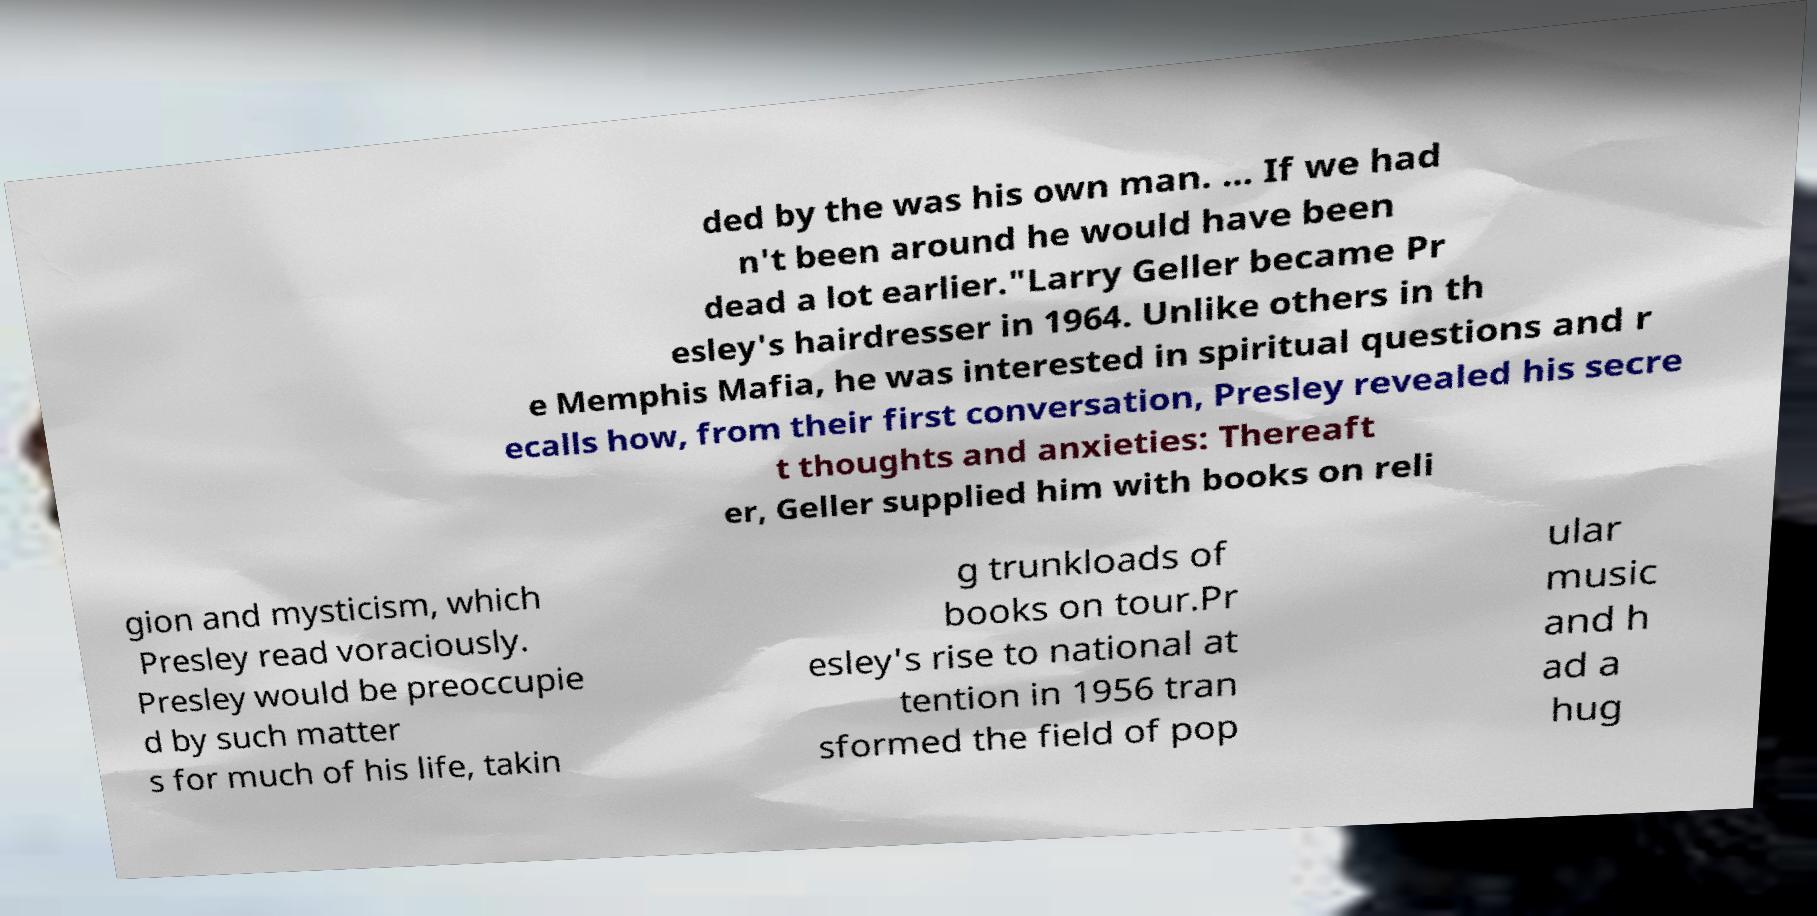What messages or text are displayed in this image? I need them in a readable, typed format. ded by the was his own man. ... If we had n't been around he would have been dead a lot earlier."Larry Geller became Pr esley's hairdresser in 1964. Unlike others in th e Memphis Mafia, he was interested in spiritual questions and r ecalls how, from their first conversation, Presley revealed his secre t thoughts and anxieties: Thereaft er, Geller supplied him with books on reli gion and mysticism, which Presley read voraciously. Presley would be preoccupie d by such matter s for much of his life, takin g trunkloads of books on tour.Pr esley's rise to national at tention in 1956 tran sformed the field of pop ular music and h ad a hug 